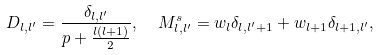<formula> <loc_0><loc_0><loc_500><loc_500>D _ { l , l ^ { \prime } } = \frac { \delta _ { l , l ^ { \prime } } } { p + \frac { l ( l + 1 ) } { 2 } } , \ \ M _ { l , l ^ { \prime } } ^ { s } = w _ { l } \delta _ { l , l ^ { \prime } + 1 } + w _ { l + 1 } \delta _ { l + 1 , l ^ { \prime } } ,</formula> 